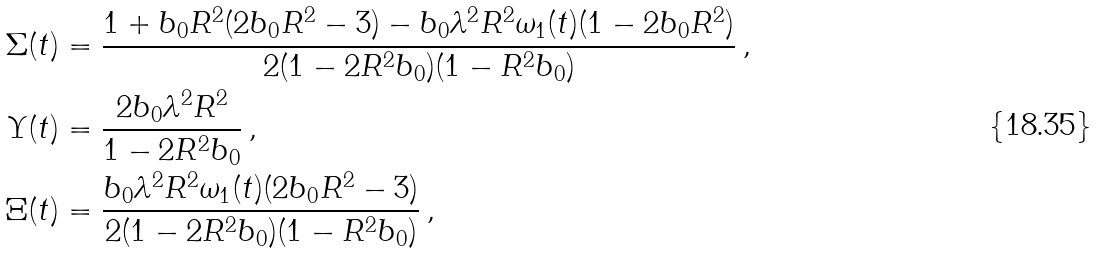Convert formula to latex. <formula><loc_0><loc_0><loc_500><loc_500>\Sigma ( t ) & = \frac { 1 + b _ { 0 } R ^ { 2 } ( 2 b _ { 0 } R ^ { 2 } - 3 ) - b _ { 0 } \lambda ^ { 2 } R ^ { 2 } \omega _ { 1 } ( t ) ( 1 - 2 b _ { 0 } R ^ { 2 } ) } { 2 ( 1 - 2 R ^ { 2 } b _ { 0 } ) ( 1 - R ^ { 2 } b _ { 0 } ) } \, , \\ \Upsilon ( t ) & = \frac { 2 b _ { 0 } \lambda ^ { 2 } R ^ { 2 } } { 1 - 2 R ^ { 2 } b _ { 0 } } \, , \\ \Xi ( t ) & = \frac { b _ { 0 } \lambda ^ { 2 } R ^ { 2 } \omega _ { 1 } ( t ) ( 2 b _ { 0 } R ^ { 2 } - 3 ) } { 2 ( 1 - 2 R ^ { 2 } b _ { 0 } ) ( 1 - R ^ { 2 } b _ { 0 } ) } \, ,</formula> 